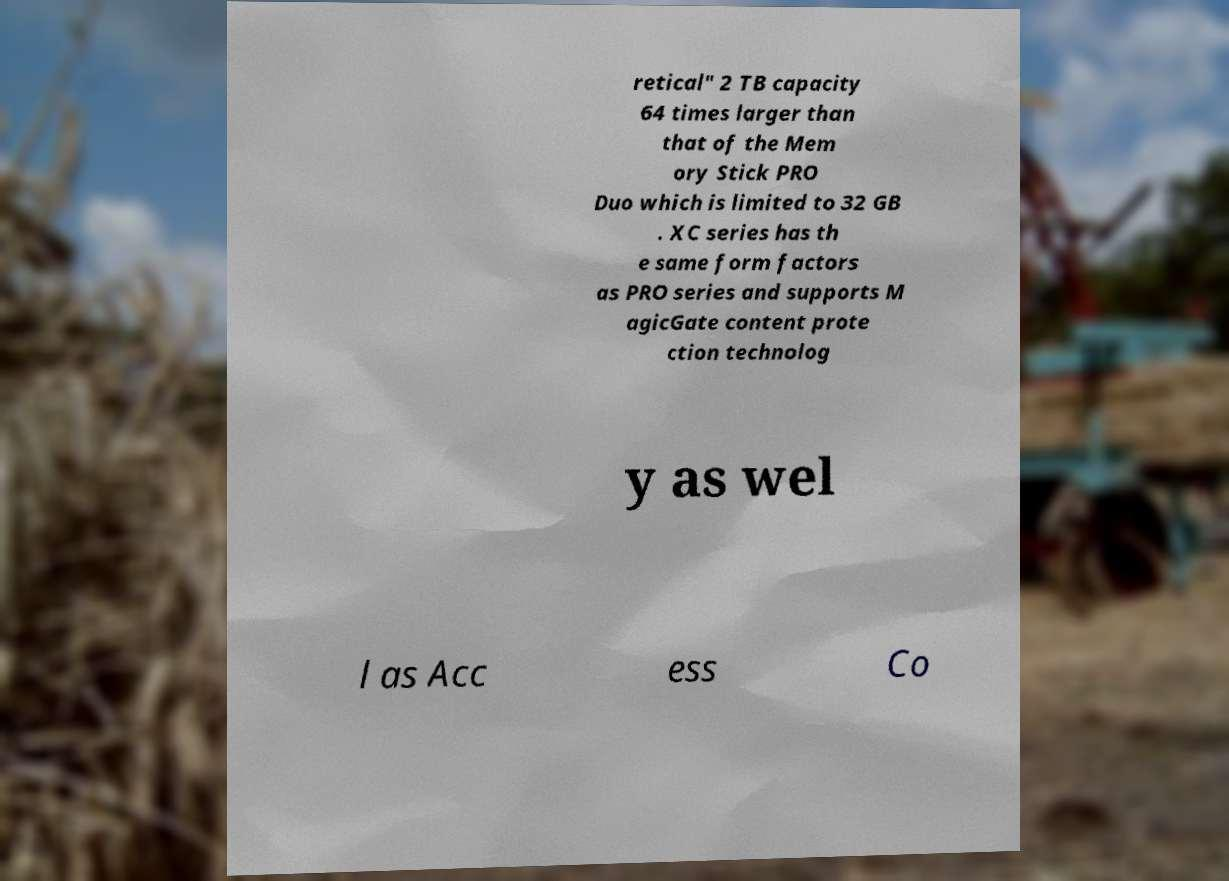Please read and relay the text visible in this image. What does it say? retical" 2 TB capacity 64 times larger than that of the Mem ory Stick PRO Duo which is limited to 32 GB . XC series has th e same form factors as PRO series and supports M agicGate content prote ction technolog y as wel l as Acc ess Co 